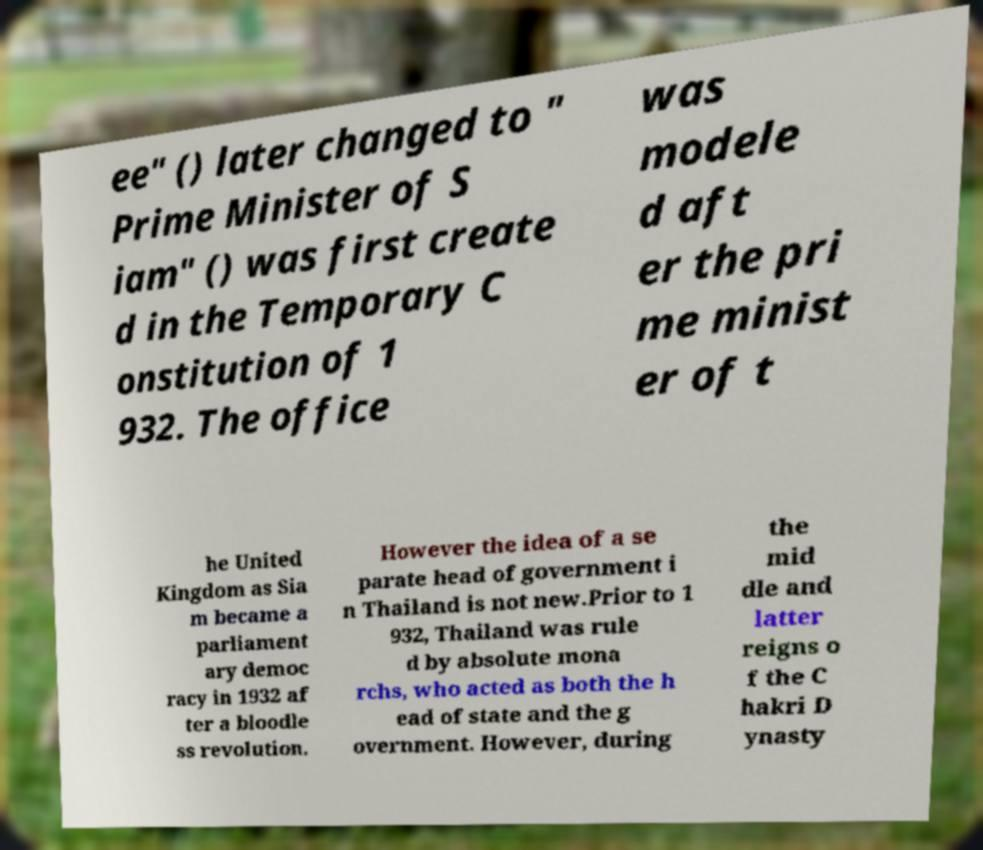There's text embedded in this image that I need extracted. Can you transcribe it verbatim? ee" () later changed to " Prime Minister of S iam" () was first create d in the Temporary C onstitution of 1 932. The office was modele d aft er the pri me minist er of t he United Kingdom as Sia m became a parliament ary democ racy in 1932 af ter a bloodle ss revolution. However the idea of a se parate head of government i n Thailand is not new.Prior to 1 932, Thailand was rule d by absolute mona rchs, who acted as both the h ead of state and the g overnment. However, during the mid dle and latter reigns o f the C hakri D ynasty 